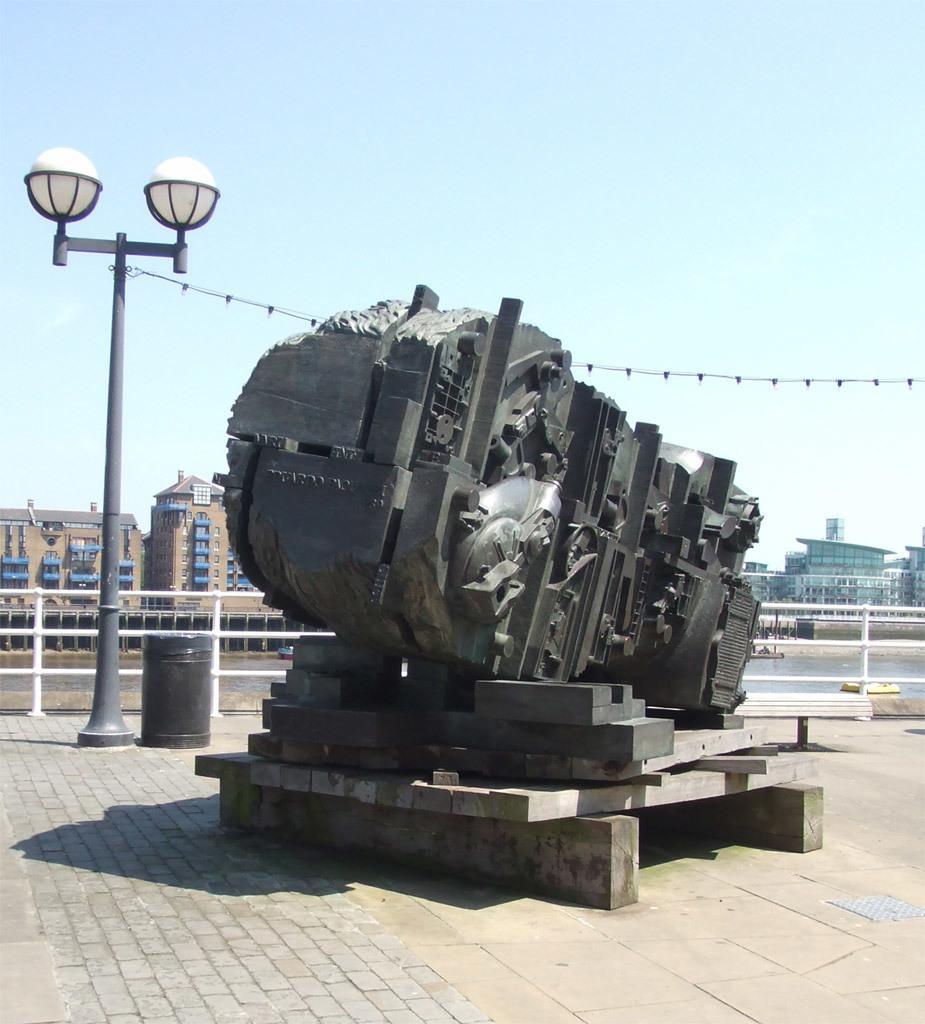Can you describe this image briefly? In the center of the image a sculpture is there. On the left side of the image a electric light pole and dustbin are present. In the background of the image buildings are there. At the top of the image sky is there. At the bottom of the image ground is present. 